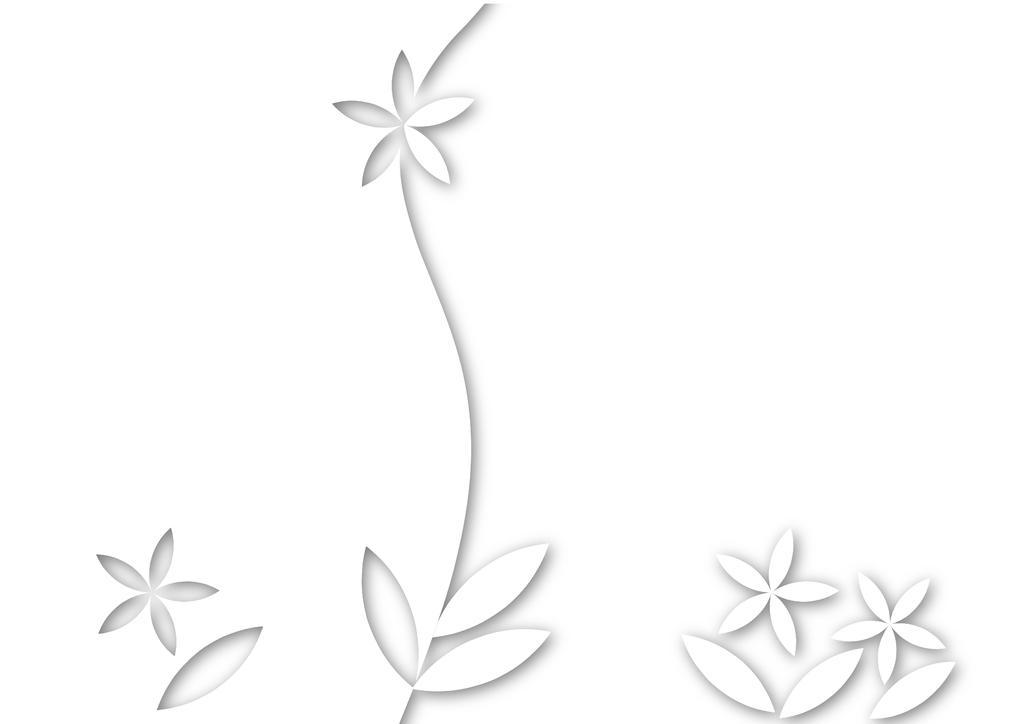How can you tell that the image has been edited? The fact that the image has been edited is mentioned, but we cannot determine how this is evident from the image itself. What type of flowers are present in the image? There are artificial flowers in the image. What color is the background of the image? The background of the image is white. What is the weight of the lock on the door in the image? There is no lock or door present in the image, so it is not possible to determine the weight of a lock. 